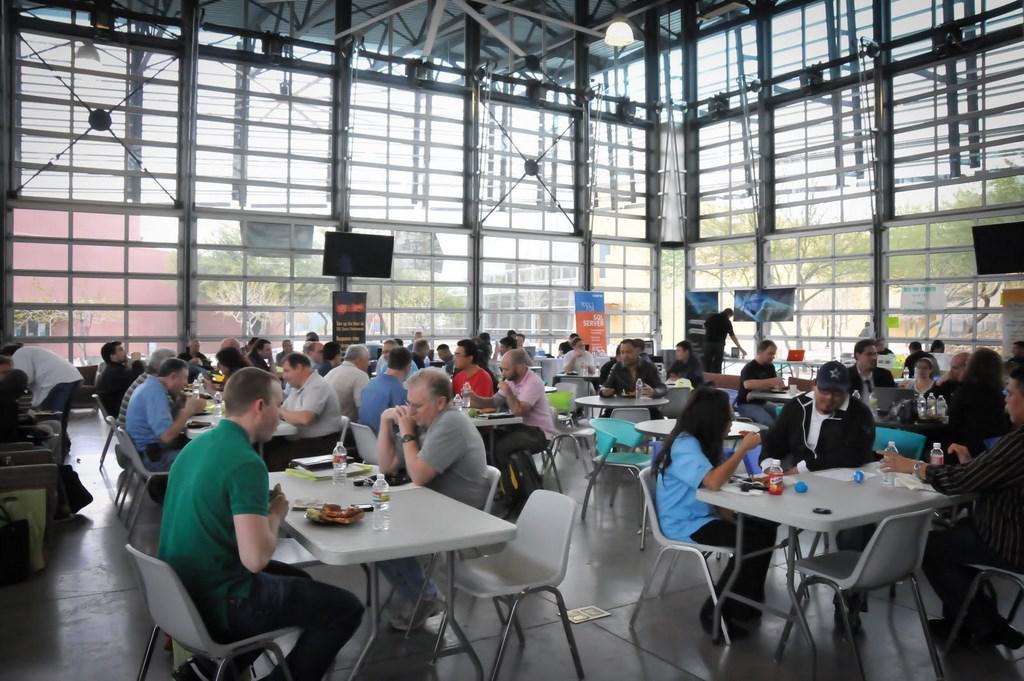Please provide a concise description of this image. In this we can see a group of persons are sitting on the chair, and in front here is the table, and bottle and plate and some objects on it, and here is the glass door, and here is the light. 